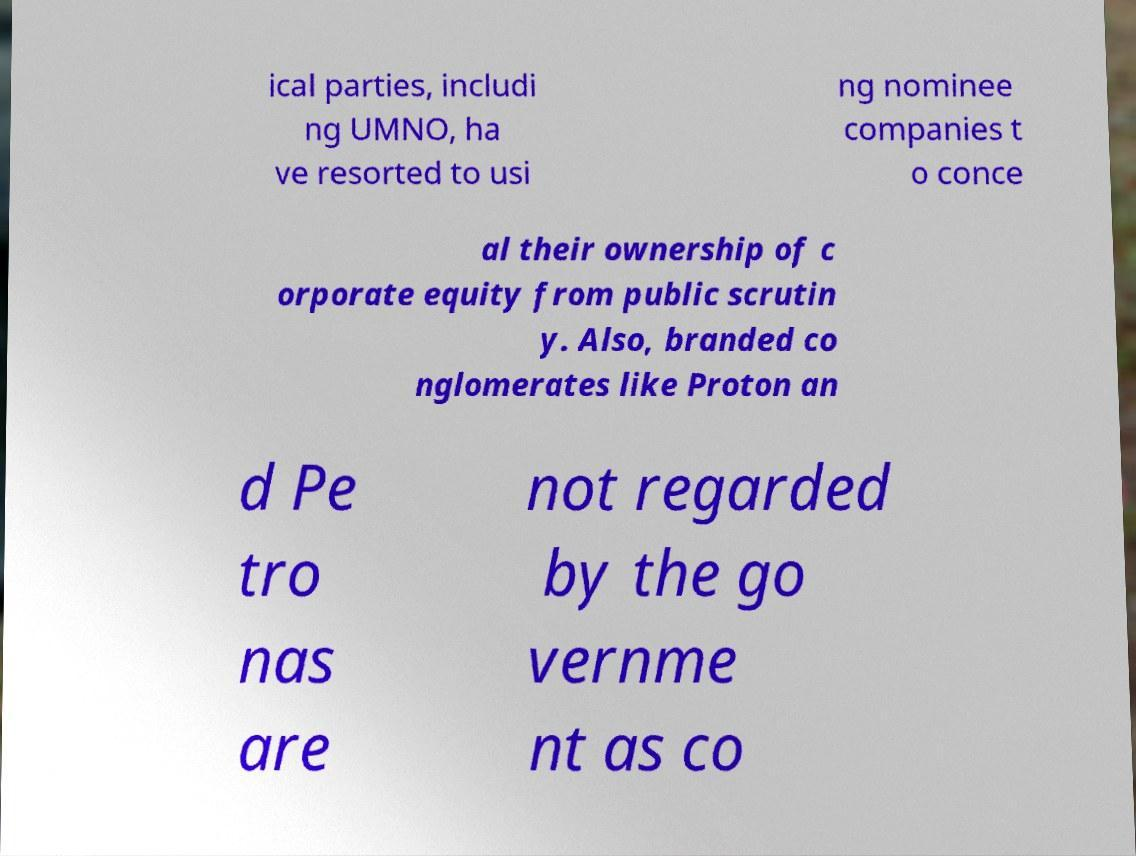Could you extract and type out the text from this image? ical parties, includi ng UMNO, ha ve resorted to usi ng nominee companies t o conce al their ownership of c orporate equity from public scrutin y. Also, branded co nglomerates like Proton an d Pe tro nas are not regarded by the go vernme nt as co 